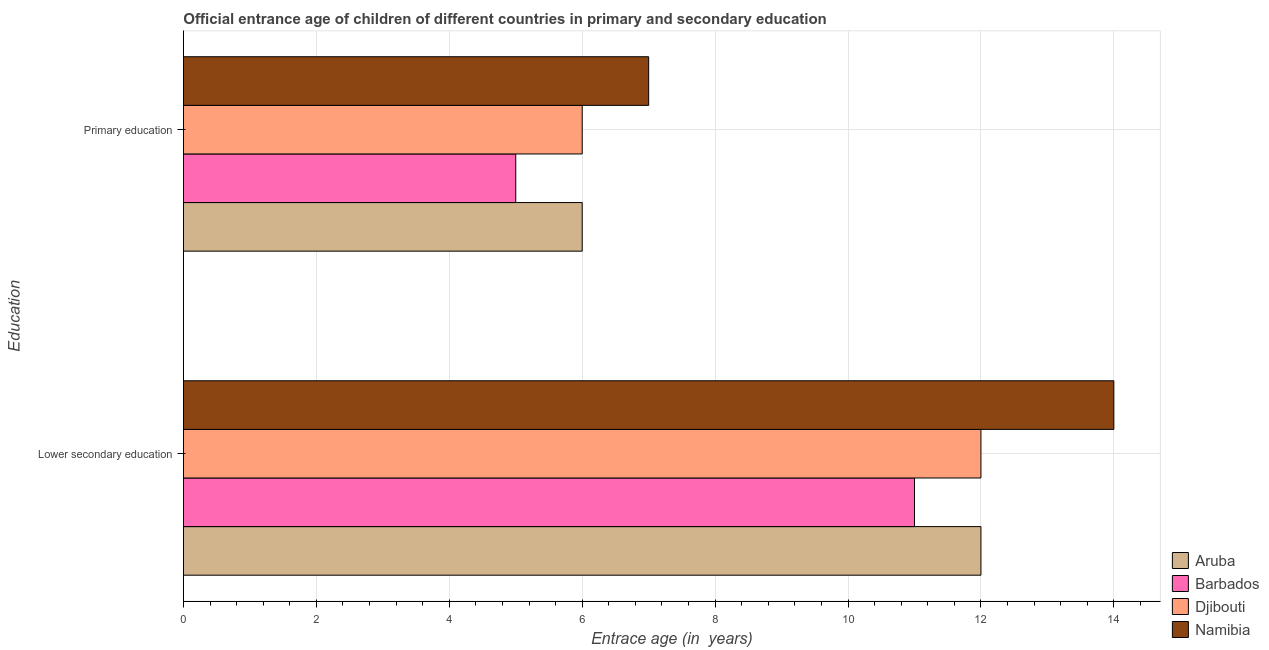How many groups of bars are there?
Provide a succinct answer. 2. How many bars are there on the 1st tick from the bottom?
Offer a very short reply. 4. What is the label of the 1st group of bars from the top?
Your response must be concise. Primary education. Across all countries, what is the maximum entrance age of chiildren in primary education?
Ensure brevity in your answer.  7. Across all countries, what is the minimum entrance age of chiildren in primary education?
Provide a succinct answer. 5. In which country was the entrance age of chiildren in primary education maximum?
Offer a very short reply. Namibia. In which country was the entrance age of children in lower secondary education minimum?
Your answer should be compact. Barbados. What is the total entrance age of chiildren in primary education in the graph?
Offer a very short reply. 24. What is the difference between the entrance age of children in lower secondary education in Djibouti and that in Barbados?
Give a very brief answer. 1. What is the difference between the entrance age of chiildren in primary education in Aruba and the entrance age of children in lower secondary education in Djibouti?
Make the answer very short. -6. What is the average entrance age of chiildren in primary education per country?
Make the answer very short. 6. What is the difference between the entrance age of chiildren in primary education and entrance age of children in lower secondary education in Namibia?
Offer a terse response. -7. In how many countries, is the entrance age of children in lower secondary education greater than 8 years?
Your answer should be compact. 4. What is the ratio of the entrance age of children in lower secondary education in Djibouti to that in Barbados?
Offer a terse response. 1.09. Is the entrance age of chiildren in primary education in Namibia less than that in Barbados?
Keep it short and to the point. No. In how many countries, is the entrance age of chiildren in primary education greater than the average entrance age of chiildren in primary education taken over all countries?
Make the answer very short. 1. What does the 3rd bar from the top in Primary education represents?
Ensure brevity in your answer.  Barbados. What does the 4th bar from the bottom in Lower secondary education represents?
Give a very brief answer. Namibia. How many bars are there?
Your answer should be very brief. 8. What is the difference between two consecutive major ticks on the X-axis?
Your answer should be very brief. 2. Are the values on the major ticks of X-axis written in scientific E-notation?
Give a very brief answer. No. Does the graph contain grids?
Keep it short and to the point. Yes. How are the legend labels stacked?
Your answer should be very brief. Vertical. What is the title of the graph?
Offer a very short reply. Official entrance age of children of different countries in primary and secondary education. What is the label or title of the X-axis?
Provide a short and direct response. Entrace age (in  years). What is the label or title of the Y-axis?
Ensure brevity in your answer.  Education. What is the Entrace age (in  years) of Aruba in Lower secondary education?
Your answer should be compact. 12. What is the Entrace age (in  years) in Barbados in Lower secondary education?
Offer a terse response. 11. What is the Entrace age (in  years) in Djibouti in Lower secondary education?
Offer a very short reply. 12. Across all Education, what is the maximum Entrace age (in  years) of Barbados?
Your answer should be compact. 11. Across all Education, what is the minimum Entrace age (in  years) in Djibouti?
Your answer should be very brief. 6. Across all Education, what is the minimum Entrace age (in  years) of Namibia?
Your answer should be very brief. 7. What is the total Entrace age (in  years) in Barbados in the graph?
Give a very brief answer. 16. What is the difference between the Entrace age (in  years) in Aruba in Lower secondary education and that in Primary education?
Your response must be concise. 6. What is the difference between the Entrace age (in  years) of Aruba in Lower secondary education and the Entrace age (in  years) of Djibouti in Primary education?
Provide a short and direct response. 6. What is the average Entrace age (in  years) in Aruba per Education?
Provide a short and direct response. 9. What is the average Entrace age (in  years) of Djibouti per Education?
Your answer should be very brief. 9. What is the average Entrace age (in  years) of Namibia per Education?
Offer a terse response. 10.5. What is the difference between the Entrace age (in  years) in Aruba and Entrace age (in  years) in Barbados in Lower secondary education?
Keep it short and to the point. 1. What is the difference between the Entrace age (in  years) in Aruba and Entrace age (in  years) in Djibouti in Lower secondary education?
Provide a short and direct response. 0. What is the difference between the Entrace age (in  years) of Aruba and Entrace age (in  years) of Namibia in Lower secondary education?
Ensure brevity in your answer.  -2. What is the difference between the Entrace age (in  years) in Barbados and Entrace age (in  years) in Namibia in Lower secondary education?
Keep it short and to the point. -3. What is the difference between the Entrace age (in  years) of Djibouti and Entrace age (in  years) of Namibia in Lower secondary education?
Make the answer very short. -2. What is the difference between the Entrace age (in  years) in Aruba and Entrace age (in  years) in Namibia in Primary education?
Ensure brevity in your answer.  -1. What is the difference between the Entrace age (in  years) of Barbados and Entrace age (in  years) of Namibia in Primary education?
Keep it short and to the point. -2. What is the ratio of the Entrace age (in  years) of Aruba in Lower secondary education to that in Primary education?
Your response must be concise. 2. What is the difference between the highest and the second highest Entrace age (in  years) of Barbados?
Make the answer very short. 6. What is the difference between the highest and the lowest Entrace age (in  years) in Aruba?
Make the answer very short. 6. What is the difference between the highest and the lowest Entrace age (in  years) in Barbados?
Offer a terse response. 6. What is the difference between the highest and the lowest Entrace age (in  years) of Namibia?
Keep it short and to the point. 7. 